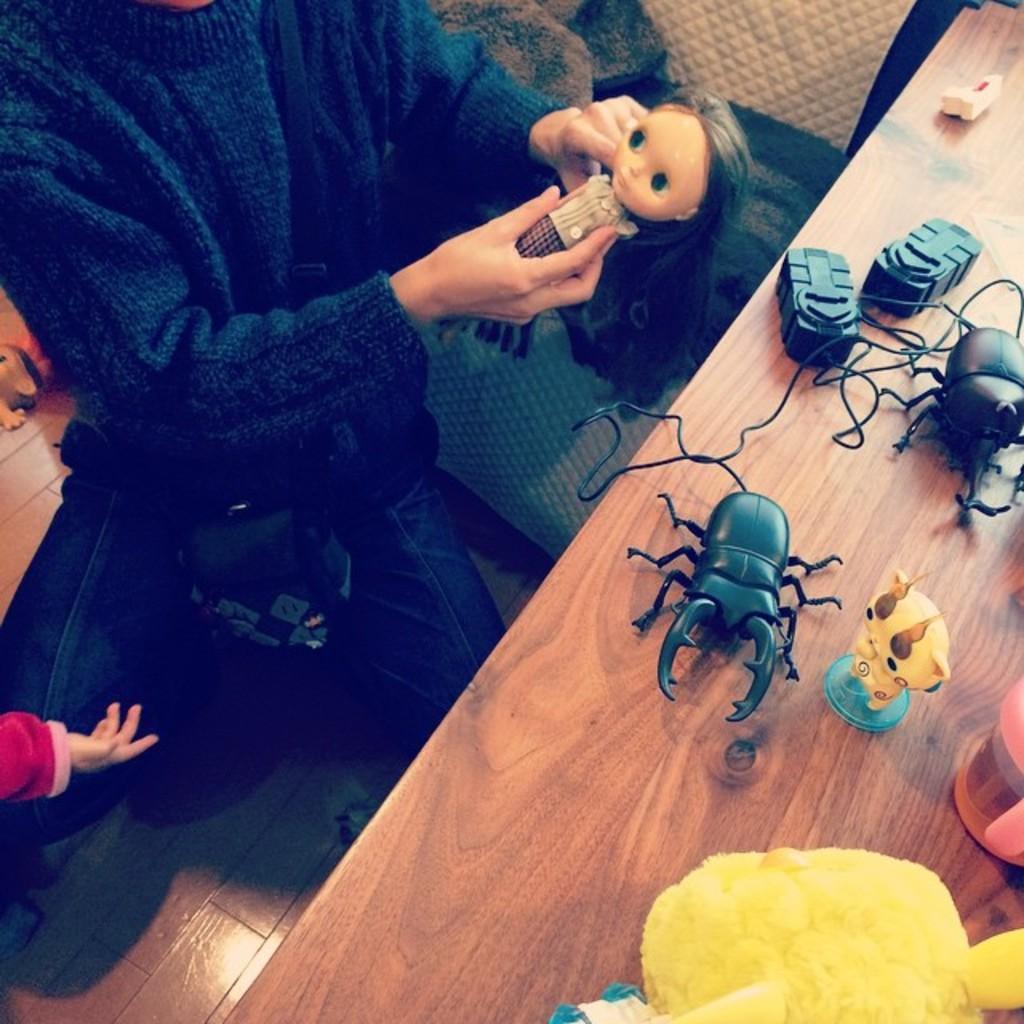Could you give a brief overview of what you see in this image? We can see a person is holding a doll in the hands and there are toys and objects on the floor. On the right side there are toys, cup and insects toys and objects on the table. 